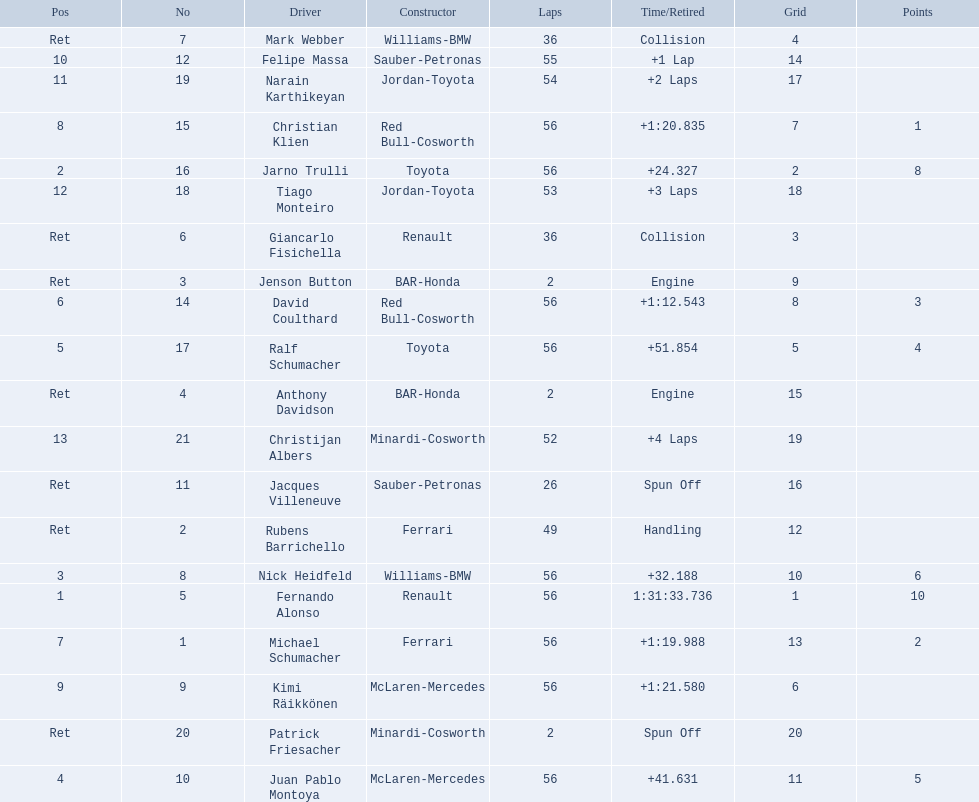Who was fernando alonso's instructor? Renault. How many laps did fernando alonso run? 56. How long did it take alonso to complete the race? 1:31:33.736. 